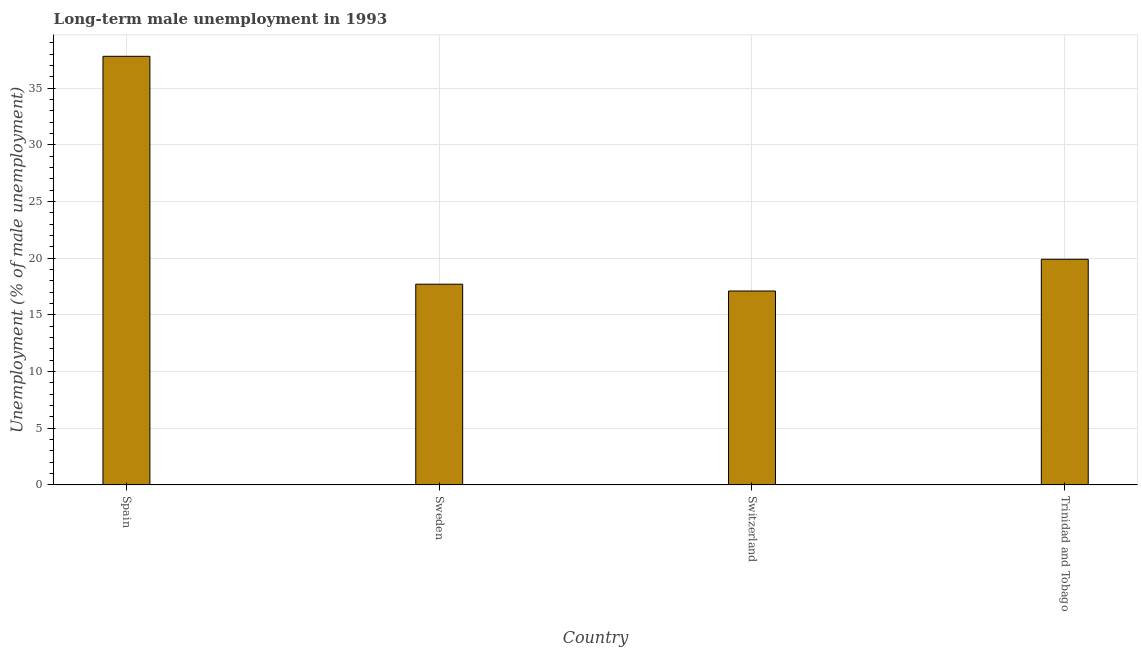Does the graph contain any zero values?
Offer a very short reply. No. Does the graph contain grids?
Ensure brevity in your answer.  Yes. What is the title of the graph?
Your answer should be very brief. Long-term male unemployment in 1993. What is the label or title of the Y-axis?
Give a very brief answer. Unemployment (% of male unemployment). What is the long-term male unemployment in Trinidad and Tobago?
Your answer should be compact. 19.9. Across all countries, what is the maximum long-term male unemployment?
Make the answer very short. 37.8. Across all countries, what is the minimum long-term male unemployment?
Give a very brief answer. 17.1. In which country was the long-term male unemployment minimum?
Make the answer very short. Switzerland. What is the sum of the long-term male unemployment?
Ensure brevity in your answer.  92.5. What is the average long-term male unemployment per country?
Provide a short and direct response. 23.12. What is the median long-term male unemployment?
Ensure brevity in your answer.  18.8. In how many countries, is the long-term male unemployment greater than 10 %?
Provide a short and direct response. 4. What is the ratio of the long-term male unemployment in Spain to that in Sweden?
Provide a succinct answer. 2.14. Is the long-term male unemployment in Sweden less than that in Trinidad and Tobago?
Provide a short and direct response. Yes. Is the sum of the long-term male unemployment in Spain and Trinidad and Tobago greater than the maximum long-term male unemployment across all countries?
Provide a short and direct response. Yes. What is the difference between the highest and the lowest long-term male unemployment?
Your response must be concise. 20.7. In how many countries, is the long-term male unemployment greater than the average long-term male unemployment taken over all countries?
Keep it short and to the point. 1. Are all the bars in the graph horizontal?
Make the answer very short. No. What is the difference between two consecutive major ticks on the Y-axis?
Make the answer very short. 5. What is the Unemployment (% of male unemployment) of Spain?
Make the answer very short. 37.8. What is the Unemployment (% of male unemployment) in Sweden?
Your response must be concise. 17.7. What is the Unemployment (% of male unemployment) of Switzerland?
Offer a terse response. 17.1. What is the Unemployment (% of male unemployment) in Trinidad and Tobago?
Your answer should be compact. 19.9. What is the difference between the Unemployment (% of male unemployment) in Spain and Sweden?
Ensure brevity in your answer.  20.1. What is the difference between the Unemployment (% of male unemployment) in Spain and Switzerland?
Provide a short and direct response. 20.7. What is the ratio of the Unemployment (% of male unemployment) in Spain to that in Sweden?
Ensure brevity in your answer.  2.14. What is the ratio of the Unemployment (% of male unemployment) in Spain to that in Switzerland?
Provide a succinct answer. 2.21. What is the ratio of the Unemployment (% of male unemployment) in Spain to that in Trinidad and Tobago?
Provide a short and direct response. 1.9. What is the ratio of the Unemployment (% of male unemployment) in Sweden to that in Switzerland?
Ensure brevity in your answer.  1.03. What is the ratio of the Unemployment (% of male unemployment) in Sweden to that in Trinidad and Tobago?
Make the answer very short. 0.89. What is the ratio of the Unemployment (% of male unemployment) in Switzerland to that in Trinidad and Tobago?
Ensure brevity in your answer.  0.86. 